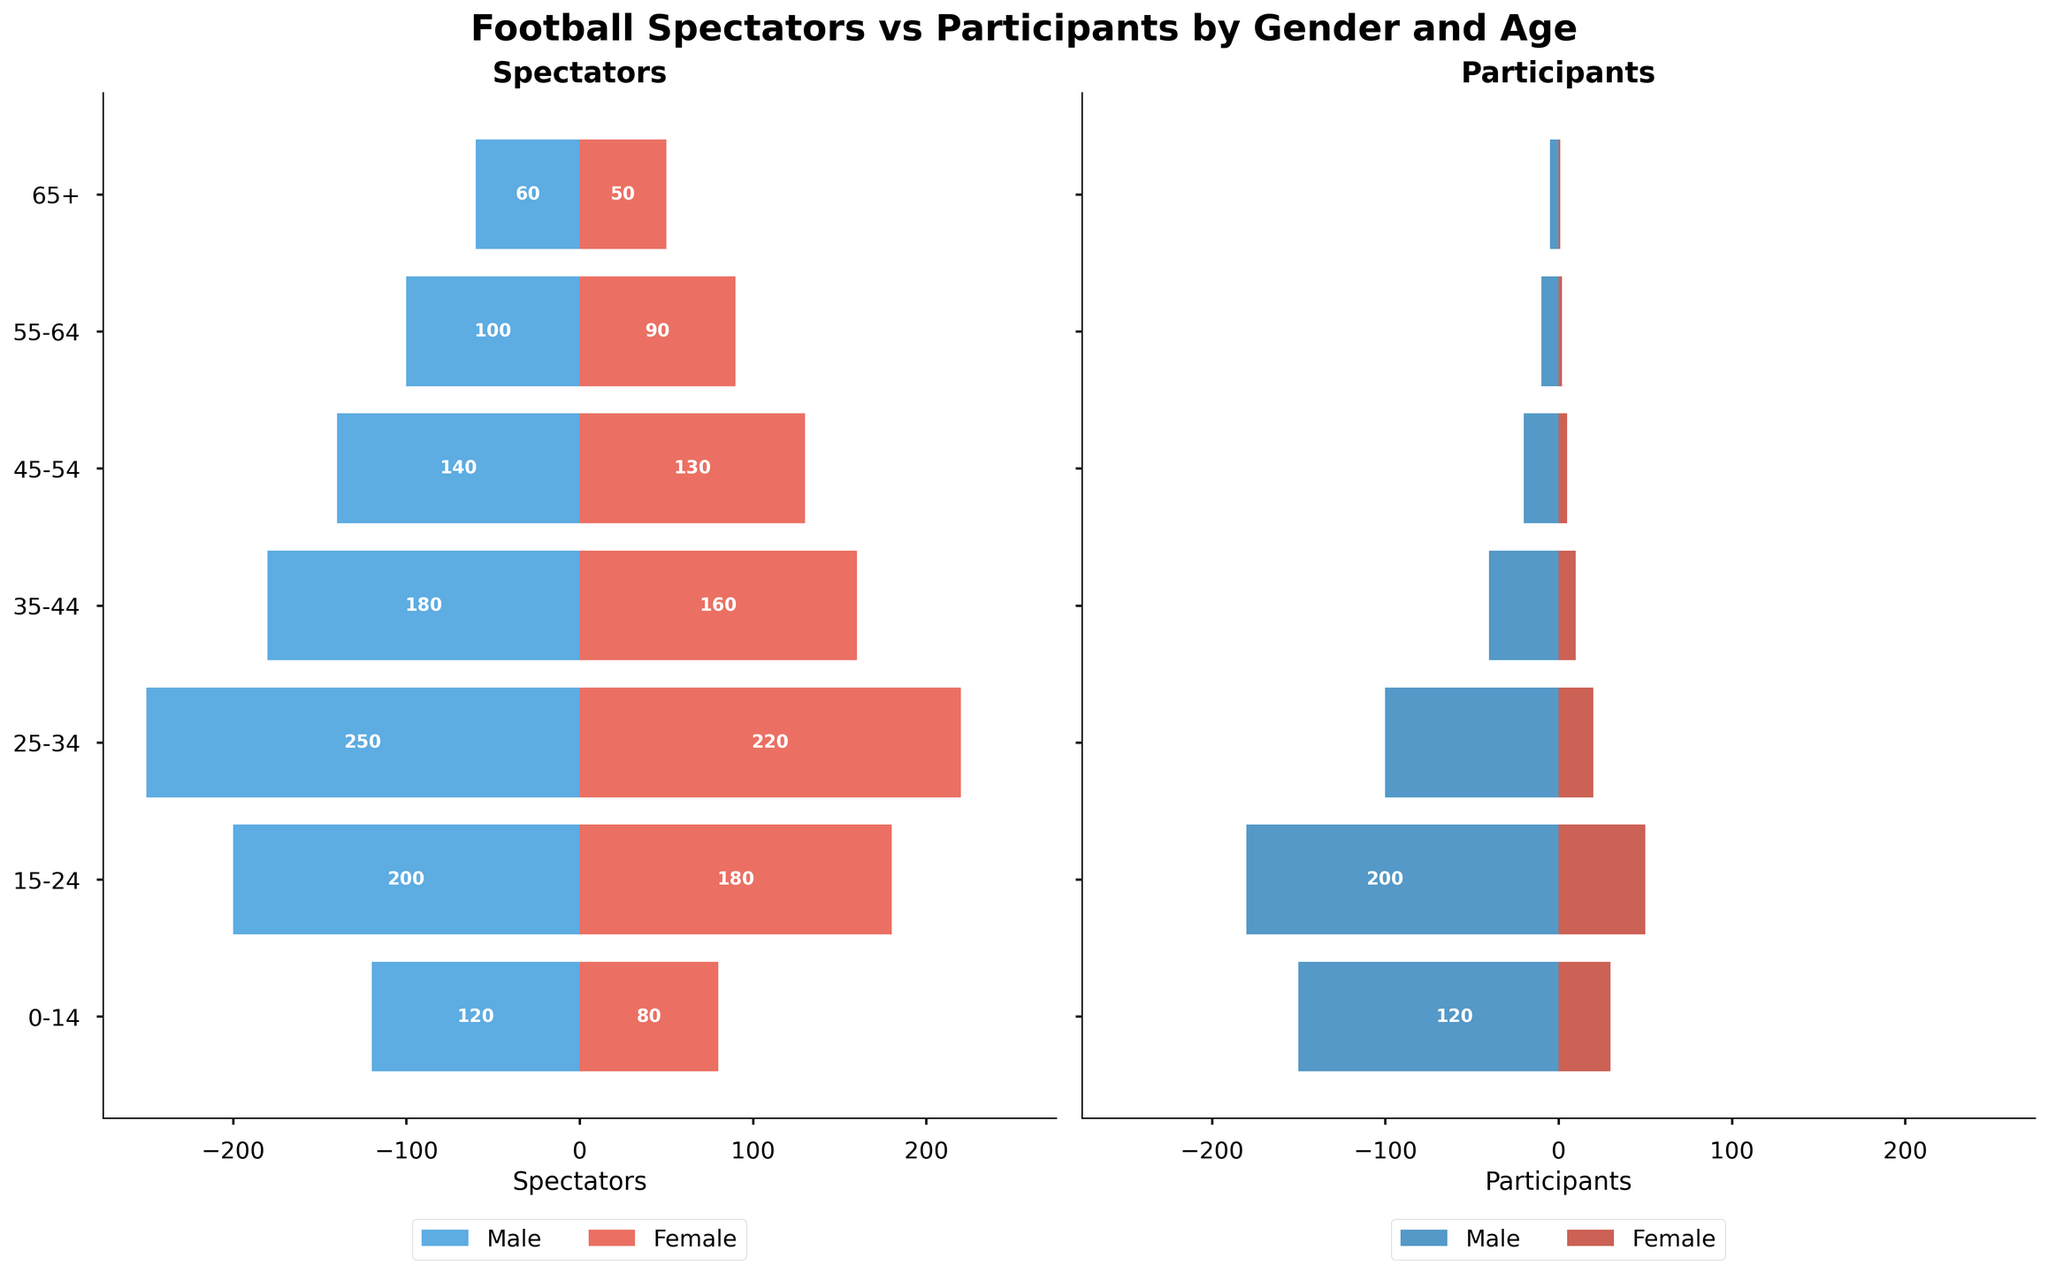What is the main title of the figure? The main title is usually displayed at the top of the figure, summarizing the content it represents.
Answer: Football Spectators vs Participants by Gender and Age Which age group has the most male spectators? By looking at the lengths of the bars in the "Spectators" section, the age group with the longest bar on the negative side for males is the one with the most male spectators.
Answer: 25-34 Are there more female spectators or female participants in the 15-24 age group? Compare the lengths of the bars for female spectators and participants in the 15-24 age group to determine which is longer.
Answer: Female spectators What is the combined number of male participants in the 35-44 and 45-54 age groups? Sum the values for male participants in the 35-44 and 45-54 age groups: 40 (35-44) + 20 (45-54) = 60.
Answer: 60 Which gender has a larger number of spectators in the 55-64 age group? Look at the bar lengths for male and female spectators in the 55-64 age group to see which one is longer.
Answer: Male How many female participants are there in total across all age groups? Sum the numbers of female participants across all age groups: 30 + 50 + 20 + 10 + 5 + 2 + 1 = 118.
Answer: 118 In which age group is the difference between male and female participants the largest? Calculate the difference between male and female participants for each age group, and identify the largest difference. For instance: 
0-14: 150 - 30 = 120, 
15-24: 180 - 50 = 130, 
25-34: 100 - 20 = 80, 
35-44: 40 - 10 = 30, 
45-54: 20 - 5 = 15, 
55-64: 10 - 2 = 8, 
65+: 5 - 1 = 4. The largest difference is in the 15-24 age group.
Answer: 15-24 Is there an age group where the number of male spectators equals the number of female spectators? Compare the values for male and female spectators in each age group. None of the age groups have equal numbers of male and female spectators.
Answer: No What is the trend in the number of participants as the age increases from 0-14 to 65+? By examining the lengths of the bars in the "Participants" section, we can observe that the number of participants generally decreases as the age increases.
Answer: Decreasing 